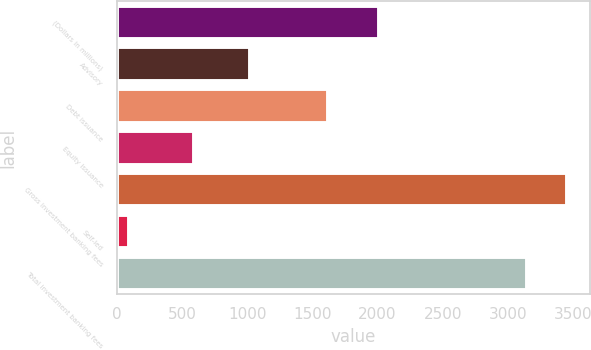Convert chart. <chart><loc_0><loc_0><loc_500><loc_500><bar_chart><fcel>(Dollars in millions)<fcel>Advisory<fcel>Debt issuance<fcel>Equity issuance<fcel>Gross investment banking fees<fcel>Self-led<fcel>Total investment banking fees<nl><fcel>2013<fcel>1022<fcel>1620<fcel>593<fcel>3457.3<fcel>92<fcel>3143<nl></chart> 